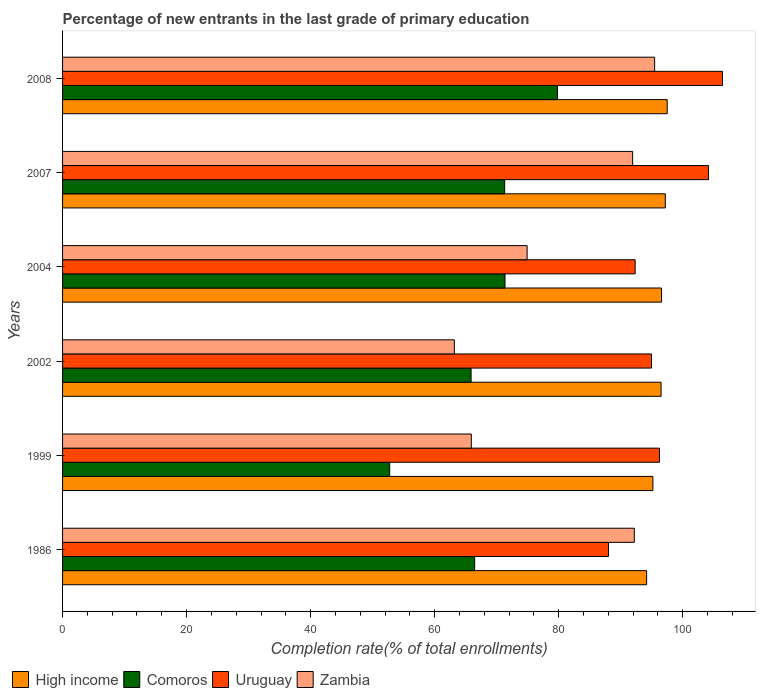How many groups of bars are there?
Your answer should be compact. 6. Are the number of bars on each tick of the Y-axis equal?
Provide a short and direct response. Yes. How many bars are there on the 1st tick from the bottom?
Provide a succinct answer. 4. What is the label of the 2nd group of bars from the top?
Your answer should be compact. 2007. In how many cases, is the number of bars for a given year not equal to the number of legend labels?
Make the answer very short. 0. What is the percentage of new entrants in Comoros in 2002?
Keep it short and to the point. 65.88. Across all years, what is the maximum percentage of new entrants in High income?
Offer a very short reply. 97.5. Across all years, what is the minimum percentage of new entrants in Uruguay?
Give a very brief answer. 88.04. What is the total percentage of new entrants in Uruguay in the graph?
Offer a very short reply. 582.19. What is the difference between the percentage of new entrants in High income in 1986 and that in 2008?
Offer a very short reply. -3.32. What is the difference between the percentage of new entrants in Uruguay in 2008 and the percentage of new entrants in Comoros in 2007?
Your response must be concise. 35.12. What is the average percentage of new entrants in Comoros per year?
Your answer should be very brief. 67.92. In the year 2004, what is the difference between the percentage of new entrants in High income and percentage of new entrants in Zambia?
Your answer should be very brief. 21.68. In how many years, is the percentage of new entrants in Uruguay greater than 60 %?
Provide a succinct answer. 6. What is the ratio of the percentage of new entrants in High income in 2002 to that in 2007?
Provide a succinct answer. 0.99. Is the difference between the percentage of new entrants in High income in 1986 and 2007 greater than the difference between the percentage of new entrants in Zambia in 1986 and 2007?
Your answer should be very brief. No. What is the difference between the highest and the second highest percentage of new entrants in Zambia?
Your answer should be compact. 3.28. What is the difference between the highest and the lowest percentage of new entrants in Comoros?
Give a very brief answer. 27.06. In how many years, is the percentage of new entrants in Comoros greater than the average percentage of new entrants in Comoros taken over all years?
Your answer should be very brief. 3. Is it the case that in every year, the sum of the percentage of new entrants in Uruguay and percentage of new entrants in Comoros is greater than the sum of percentage of new entrants in Zambia and percentage of new entrants in High income?
Your answer should be compact. No. What does the 1st bar from the top in 2002 represents?
Your response must be concise. Zambia. What does the 3rd bar from the bottom in 1999 represents?
Ensure brevity in your answer.  Uruguay. Is it the case that in every year, the sum of the percentage of new entrants in Zambia and percentage of new entrants in Uruguay is greater than the percentage of new entrants in High income?
Ensure brevity in your answer.  Yes. How many bars are there?
Offer a very short reply. 24. Are all the bars in the graph horizontal?
Offer a very short reply. Yes. How many years are there in the graph?
Provide a succinct answer. 6. Are the values on the major ticks of X-axis written in scientific E-notation?
Keep it short and to the point. No. Does the graph contain any zero values?
Provide a succinct answer. No. Does the graph contain grids?
Offer a very short reply. No. Where does the legend appear in the graph?
Your answer should be compact. Bottom left. How many legend labels are there?
Provide a succinct answer. 4. How are the legend labels stacked?
Give a very brief answer. Horizontal. What is the title of the graph?
Your answer should be very brief. Percentage of new entrants in the last grade of primary education. What is the label or title of the X-axis?
Keep it short and to the point. Completion rate(% of total enrollments). What is the label or title of the Y-axis?
Provide a succinct answer. Years. What is the Completion rate(% of total enrollments) of High income in 1986?
Your response must be concise. 94.19. What is the Completion rate(% of total enrollments) of Comoros in 1986?
Keep it short and to the point. 66.46. What is the Completion rate(% of total enrollments) in Uruguay in 1986?
Your response must be concise. 88.04. What is the Completion rate(% of total enrollments) of Zambia in 1986?
Your answer should be very brief. 92.2. What is the Completion rate(% of total enrollments) of High income in 1999?
Offer a very short reply. 95.2. What is the Completion rate(% of total enrollments) in Comoros in 1999?
Give a very brief answer. 52.75. What is the Completion rate(% of total enrollments) of Uruguay in 1999?
Provide a succinct answer. 96.25. What is the Completion rate(% of total enrollments) in Zambia in 1999?
Give a very brief answer. 65.92. What is the Completion rate(% of total enrollments) in High income in 2002?
Provide a short and direct response. 96.52. What is the Completion rate(% of total enrollments) in Comoros in 2002?
Offer a very short reply. 65.88. What is the Completion rate(% of total enrollments) in Uruguay in 2002?
Offer a terse response. 94.98. What is the Completion rate(% of total enrollments) of Zambia in 2002?
Provide a short and direct response. 63.18. What is the Completion rate(% of total enrollments) in High income in 2004?
Your answer should be very brief. 96.59. What is the Completion rate(% of total enrollments) of Comoros in 2004?
Your answer should be compact. 71.35. What is the Completion rate(% of total enrollments) in Uruguay in 2004?
Your answer should be very brief. 92.34. What is the Completion rate(% of total enrollments) in Zambia in 2004?
Offer a very short reply. 74.91. What is the Completion rate(% of total enrollments) in High income in 2007?
Provide a succinct answer. 97.2. What is the Completion rate(% of total enrollments) of Comoros in 2007?
Make the answer very short. 71.3. What is the Completion rate(% of total enrollments) in Uruguay in 2007?
Give a very brief answer. 104.17. What is the Completion rate(% of total enrollments) in Zambia in 2007?
Offer a very short reply. 91.93. What is the Completion rate(% of total enrollments) of High income in 2008?
Give a very brief answer. 97.5. What is the Completion rate(% of total enrollments) in Comoros in 2008?
Give a very brief answer. 79.82. What is the Completion rate(% of total enrollments) in Uruguay in 2008?
Your answer should be compact. 106.42. What is the Completion rate(% of total enrollments) of Zambia in 2008?
Give a very brief answer. 95.47. Across all years, what is the maximum Completion rate(% of total enrollments) in High income?
Your response must be concise. 97.5. Across all years, what is the maximum Completion rate(% of total enrollments) of Comoros?
Make the answer very short. 79.82. Across all years, what is the maximum Completion rate(% of total enrollments) of Uruguay?
Your answer should be very brief. 106.42. Across all years, what is the maximum Completion rate(% of total enrollments) of Zambia?
Your answer should be very brief. 95.47. Across all years, what is the minimum Completion rate(% of total enrollments) of High income?
Provide a succinct answer. 94.19. Across all years, what is the minimum Completion rate(% of total enrollments) in Comoros?
Your response must be concise. 52.75. Across all years, what is the minimum Completion rate(% of total enrollments) of Uruguay?
Your answer should be compact. 88.04. Across all years, what is the minimum Completion rate(% of total enrollments) of Zambia?
Provide a short and direct response. 63.18. What is the total Completion rate(% of total enrollments) of High income in the graph?
Give a very brief answer. 577.19. What is the total Completion rate(% of total enrollments) of Comoros in the graph?
Give a very brief answer. 407.54. What is the total Completion rate(% of total enrollments) in Uruguay in the graph?
Keep it short and to the point. 582.19. What is the total Completion rate(% of total enrollments) in Zambia in the graph?
Offer a very short reply. 483.61. What is the difference between the Completion rate(% of total enrollments) in High income in 1986 and that in 1999?
Offer a terse response. -1.01. What is the difference between the Completion rate(% of total enrollments) of Comoros in 1986 and that in 1999?
Offer a very short reply. 13.7. What is the difference between the Completion rate(% of total enrollments) of Uruguay in 1986 and that in 1999?
Your response must be concise. -8.22. What is the difference between the Completion rate(% of total enrollments) in Zambia in 1986 and that in 1999?
Provide a short and direct response. 26.28. What is the difference between the Completion rate(% of total enrollments) of High income in 1986 and that in 2002?
Provide a short and direct response. -2.33. What is the difference between the Completion rate(% of total enrollments) of Comoros in 1986 and that in 2002?
Offer a terse response. 0.58. What is the difference between the Completion rate(% of total enrollments) of Uruguay in 1986 and that in 2002?
Keep it short and to the point. -6.94. What is the difference between the Completion rate(% of total enrollments) of Zambia in 1986 and that in 2002?
Your response must be concise. 29.02. What is the difference between the Completion rate(% of total enrollments) in High income in 1986 and that in 2004?
Ensure brevity in your answer.  -2.41. What is the difference between the Completion rate(% of total enrollments) in Comoros in 1986 and that in 2004?
Provide a short and direct response. -4.89. What is the difference between the Completion rate(% of total enrollments) of Uruguay in 1986 and that in 2004?
Offer a very short reply. -4.3. What is the difference between the Completion rate(% of total enrollments) of Zambia in 1986 and that in 2004?
Offer a very short reply. 17.29. What is the difference between the Completion rate(% of total enrollments) in High income in 1986 and that in 2007?
Offer a terse response. -3.01. What is the difference between the Completion rate(% of total enrollments) in Comoros in 1986 and that in 2007?
Your answer should be very brief. -4.84. What is the difference between the Completion rate(% of total enrollments) in Uruguay in 1986 and that in 2007?
Offer a terse response. -16.13. What is the difference between the Completion rate(% of total enrollments) in Zambia in 1986 and that in 2007?
Offer a very short reply. 0.27. What is the difference between the Completion rate(% of total enrollments) in High income in 1986 and that in 2008?
Your answer should be very brief. -3.32. What is the difference between the Completion rate(% of total enrollments) in Comoros in 1986 and that in 2008?
Give a very brief answer. -13.36. What is the difference between the Completion rate(% of total enrollments) of Uruguay in 1986 and that in 2008?
Make the answer very short. -18.39. What is the difference between the Completion rate(% of total enrollments) of Zambia in 1986 and that in 2008?
Your response must be concise. -3.28. What is the difference between the Completion rate(% of total enrollments) in High income in 1999 and that in 2002?
Provide a short and direct response. -1.32. What is the difference between the Completion rate(% of total enrollments) of Comoros in 1999 and that in 2002?
Keep it short and to the point. -13.13. What is the difference between the Completion rate(% of total enrollments) of Uruguay in 1999 and that in 2002?
Offer a terse response. 1.28. What is the difference between the Completion rate(% of total enrollments) of Zambia in 1999 and that in 2002?
Keep it short and to the point. 2.74. What is the difference between the Completion rate(% of total enrollments) of High income in 1999 and that in 2004?
Provide a succinct answer. -1.4. What is the difference between the Completion rate(% of total enrollments) in Comoros in 1999 and that in 2004?
Provide a succinct answer. -18.6. What is the difference between the Completion rate(% of total enrollments) in Uruguay in 1999 and that in 2004?
Provide a succinct answer. 3.92. What is the difference between the Completion rate(% of total enrollments) of Zambia in 1999 and that in 2004?
Your response must be concise. -9. What is the difference between the Completion rate(% of total enrollments) in High income in 1999 and that in 2007?
Make the answer very short. -2. What is the difference between the Completion rate(% of total enrollments) in Comoros in 1999 and that in 2007?
Offer a terse response. -18.55. What is the difference between the Completion rate(% of total enrollments) in Uruguay in 1999 and that in 2007?
Offer a very short reply. -7.91. What is the difference between the Completion rate(% of total enrollments) in Zambia in 1999 and that in 2007?
Your answer should be compact. -26.02. What is the difference between the Completion rate(% of total enrollments) of High income in 1999 and that in 2008?
Your response must be concise. -2.31. What is the difference between the Completion rate(% of total enrollments) of Comoros in 1999 and that in 2008?
Your response must be concise. -27.06. What is the difference between the Completion rate(% of total enrollments) in Uruguay in 1999 and that in 2008?
Give a very brief answer. -10.17. What is the difference between the Completion rate(% of total enrollments) in Zambia in 1999 and that in 2008?
Ensure brevity in your answer.  -29.56. What is the difference between the Completion rate(% of total enrollments) of High income in 2002 and that in 2004?
Provide a succinct answer. -0.08. What is the difference between the Completion rate(% of total enrollments) of Comoros in 2002 and that in 2004?
Your response must be concise. -5.47. What is the difference between the Completion rate(% of total enrollments) of Uruguay in 2002 and that in 2004?
Offer a terse response. 2.64. What is the difference between the Completion rate(% of total enrollments) in Zambia in 2002 and that in 2004?
Keep it short and to the point. -11.74. What is the difference between the Completion rate(% of total enrollments) of High income in 2002 and that in 2007?
Give a very brief answer. -0.68. What is the difference between the Completion rate(% of total enrollments) in Comoros in 2002 and that in 2007?
Your answer should be very brief. -5.42. What is the difference between the Completion rate(% of total enrollments) of Uruguay in 2002 and that in 2007?
Offer a very short reply. -9.19. What is the difference between the Completion rate(% of total enrollments) in Zambia in 2002 and that in 2007?
Ensure brevity in your answer.  -28.75. What is the difference between the Completion rate(% of total enrollments) in High income in 2002 and that in 2008?
Provide a short and direct response. -0.99. What is the difference between the Completion rate(% of total enrollments) of Comoros in 2002 and that in 2008?
Offer a very short reply. -13.94. What is the difference between the Completion rate(% of total enrollments) in Uruguay in 2002 and that in 2008?
Give a very brief answer. -11.44. What is the difference between the Completion rate(% of total enrollments) of Zambia in 2002 and that in 2008?
Offer a very short reply. -32.3. What is the difference between the Completion rate(% of total enrollments) of High income in 2004 and that in 2007?
Your response must be concise. -0.61. What is the difference between the Completion rate(% of total enrollments) of Comoros in 2004 and that in 2007?
Offer a terse response. 0.05. What is the difference between the Completion rate(% of total enrollments) of Uruguay in 2004 and that in 2007?
Provide a succinct answer. -11.83. What is the difference between the Completion rate(% of total enrollments) in Zambia in 2004 and that in 2007?
Make the answer very short. -17.02. What is the difference between the Completion rate(% of total enrollments) in High income in 2004 and that in 2008?
Make the answer very short. -0.91. What is the difference between the Completion rate(% of total enrollments) of Comoros in 2004 and that in 2008?
Your answer should be very brief. -8.47. What is the difference between the Completion rate(% of total enrollments) in Uruguay in 2004 and that in 2008?
Give a very brief answer. -14.08. What is the difference between the Completion rate(% of total enrollments) in Zambia in 2004 and that in 2008?
Your answer should be very brief. -20.56. What is the difference between the Completion rate(% of total enrollments) of High income in 2007 and that in 2008?
Provide a short and direct response. -0.3. What is the difference between the Completion rate(% of total enrollments) of Comoros in 2007 and that in 2008?
Provide a succinct answer. -8.52. What is the difference between the Completion rate(% of total enrollments) in Uruguay in 2007 and that in 2008?
Ensure brevity in your answer.  -2.25. What is the difference between the Completion rate(% of total enrollments) of Zambia in 2007 and that in 2008?
Keep it short and to the point. -3.54. What is the difference between the Completion rate(% of total enrollments) in High income in 1986 and the Completion rate(% of total enrollments) in Comoros in 1999?
Your response must be concise. 41.44. What is the difference between the Completion rate(% of total enrollments) in High income in 1986 and the Completion rate(% of total enrollments) in Uruguay in 1999?
Provide a succinct answer. -2.07. What is the difference between the Completion rate(% of total enrollments) in High income in 1986 and the Completion rate(% of total enrollments) in Zambia in 1999?
Keep it short and to the point. 28.27. What is the difference between the Completion rate(% of total enrollments) of Comoros in 1986 and the Completion rate(% of total enrollments) of Uruguay in 1999?
Keep it short and to the point. -29.8. What is the difference between the Completion rate(% of total enrollments) of Comoros in 1986 and the Completion rate(% of total enrollments) of Zambia in 1999?
Offer a very short reply. 0.54. What is the difference between the Completion rate(% of total enrollments) in Uruguay in 1986 and the Completion rate(% of total enrollments) in Zambia in 1999?
Provide a short and direct response. 22.12. What is the difference between the Completion rate(% of total enrollments) of High income in 1986 and the Completion rate(% of total enrollments) of Comoros in 2002?
Your answer should be compact. 28.31. What is the difference between the Completion rate(% of total enrollments) of High income in 1986 and the Completion rate(% of total enrollments) of Uruguay in 2002?
Give a very brief answer. -0.79. What is the difference between the Completion rate(% of total enrollments) in High income in 1986 and the Completion rate(% of total enrollments) in Zambia in 2002?
Offer a terse response. 31.01. What is the difference between the Completion rate(% of total enrollments) of Comoros in 1986 and the Completion rate(% of total enrollments) of Uruguay in 2002?
Provide a succinct answer. -28.52. What is the difference between the Completion rate(% of total enrollments) of Comoros in 1986 and the Completion rate(% of total enrollments) of Zambia in 2002?
Your answer should be compact. 3.28. What is the difference between the Completion rate(% of total enrollments) of Uruguay in 1986 and the Completion rate(% of total enrollments) of Zambia in 2002?
Make the answer very short. 24.86. What is the difference between the Completion rate(% of total enrollments) in High income in 1986 and the Completion rate(% of total enrollments) in Comoros in 2004?
Provide a succinct answer. 22.84. What is the difference between the Completion rate(% of total enrollments) of High income in 1986 and the Completion rate(% of total enrollments) of Uruguay in 2004?
Provide a succinct answer. 1.85. What is the difference between the Completion rate(% of total enrollments) in High income in 1986 and the Completion rate(% of total enrollments) in Zambia in 2004?
Give a very brief answer. 19.27. What is the difference between the Completion rate(% of total enrollments) in Comoros in 1986 and the Completion rate(% of total enrollments) in Uruguay in 2004?
Provide a short and direct response. -25.88. What is the difference between the Completion rate(% of total enrollments) of Comoros in 1986 and the Completion rate(% of total enrollments) of Zambia in 2004?
Give a very brief answer. -8.46. What is the difference between the Completion rate(% of total enrollments) of Uruguay in 1986 and the Completion rate(% of total enrollments) of Zambia in 2004?
Give a very brief answer. 13.12. What is the difference between the Completion rate(% of total enrollments) of High income in 1986 and the Completion rate(% of total enrollments) of Comoros in 2007?
Provide a short and direct response. 22.89. What is the difference between the Completion rate(% of total enrollments) of High income in 1986 and the Completion rate(% of total enrollments) of Uruguay in 2007?
Your answer should be compact. -9.98. What is the difference between the Completion rate(% of total enrollments) in High income in 1986 and the Completion rate(% of total enrollments) in Zambia in 2007?
Keep it short and to the point. 2.25. What is the difference between the Completion rate(% of total enrollments) of Comoros in 1986 and the Completion rate(% of total enrollments) of Uruguay in 2007?
Keep it short and to the point. -37.71. What is the difference between the Completion rate(% of total enrollments) in Comoros in 1986 and the Completion rate(% of total enrollments) in Zambia in 2007?
Keep it short and to the point. -25.48. What is the difference between the Completion rate(% of total enrollments) of Uruguay in 1986 and the Completion rate(% of total enrollments) of Zambia in 2007?
Provide a short and direct response. -3.9. What is the difference between the Completion rate(% of total enrollments) of High income in 1986 and the Completion rate(% of total enrollments) of Comoros in 2008?
Keep it short and to the point. 14.37. What is the difference between the Completion rate(% of total enrollments) in High income in 1986 and the Completion rate(% of total enrollments) in Uruguay in 2008?
Make the answer very short. -12.23. What is the difference between the Completion rate(% of total enrollments) of High income in 1986 and the Completion rate(% of total enrollments) of Zambia in 2008?
Provide a short and direct response. -1.29. What is the difference between the Completion rate(% of total enrollments) of Comoros in 1986 and the Completion rate(% of total enrollments) of Uruguay in 2008?
Provide a short and direct response. -39.96. What is the difference between the Completion rate(% of total enrollments) in Comoros in 1986 and the Completion rate(% of total enrollments) in Zambia in 2008?
Your response must be concise. -29.02. What is the difference between the Completion rate(% of total enrollments) of Uruguay in 1986 and the Completion rate(% of total enrollments) of Zambia in 2008?
Offer a terse response. -7.44. What is the difference between the Completion rate(% of total enrollments) of High income in 1999 and the Completion rate(% of total enrollments) of Comoros in 2002?
Provide a succinct answer. 29.32. What is the difference between the Completion rate(% of total enrollments) in High income in 1999 and the Completion rate(% of total enrollments) in Uruguay in 2002?
Your response must be concise. 0.22. What is the difference between the Completion rate(% of total enrollments) in High income in 1999 and the Completion rate(% of total enrollments) in Zambia in 2002?
Provide a short and direct response. 32.02. What is the difference between the Completion rate(% of total enrollments) in Comoros in 1999 and the Completion rate(% of total enrollments) in Uruguay in 2002?
Keep it short and to the point. -42.23. What is the difference between the Completion rate(% of total enrollments) of Comoros in 1999 and the Completion rate(% of total enrollments) of Zambia in 2002?
Your answer should be compact. -10.43. What is the difference between the Completion rate(% of total enrollments) of Uruguay in 1999 and the Completion rate(% of total enrollments) of Zambia in 2002?
Offer a very short reply. 33.08. What is the difference between the Completion rate(% of total enrollments) in High income in 1999 and the Completion rate(% of total enrollments) in Comoros in 2004?
Your response must be concise. 23.85. What is the difference between the Completion rate(% of total enrollments) of High income in 1999 and the Completion rate(% of total enrollments) of Uruguay in 2004?
Provide a short and direct response. 2.86. What is the difference between the Completion rate(% of total enrollments) of High income in 1999 and the Completion rate(% of total enrollments) of Zambia in 2004?
Offer a very short reply. 20.28. What is the difference between the Completion rate(% of total enrollments) in Comoros in 1999 and the Completion rate(% of total enrollments) in Uruguay in 2004?
Give a very brief answer. -39.59. What is the difference between the Completion rate(% of total enrollments) of Comoros in 1999 and the Completion rate(% of total enrollments) of Zambia in 2004?
Make the answer very short. -22.16. What is the difference between the Completion rate(% of total enrollments) of Uruguay in 1999 and the Completion rate(% of total enrollments) of Zambia in 2004?
Give a very brief answer. 21.34. What is the difference between the Completion rate(% of total enrollments) in High income in 1999 and the Completion rate(% of total enrollments) in Comoros in 2007?
Ensure brevity in your answer.  23.9. What is the difference between the Completion rate(% of total enrollments) of High income in 1999 and the Completion rate(% of total enrollments) of Uruguay in 2007?
Offer a very short reply. -8.97. What is the difference between the Completion rate(% of total enrollments) in High income in 1999 and the Completion rate(% of total enrollments) in Zambia in 2007?
Give a very brief answer. 3.26. What is the difference between the Completion rate(% of total enrollments) of Comoros in 1999 and the Completion rate(% of total enrollments) of Uruguay in 2007?
Your answer should be compact. -51.42. What is the difference between the Completion rate(% of total enrollments) of Comoros in 1999 and the Completion rate(% of total enrollments) of Zambia in 2007?
Offer a very short reply. -39.18. What is the difference between the Completion rate(% of total enrollments) of Uruguay in 1999 and the Completion rate(% of total enrollments) of Zambia in 2007?
Ensure brevity in your answer.  4.32. What is the difference between the Completion rate(% of total enrollments) in High income in 1999 and the Completion rate(% of total enrollments) in Comoros in 2008?
Your answer should be compact. 15.38. What is the difference between the Completion rate(% of total enrollments) of High income in 1999 and the Completion rate(% of total enrollments) of Uruguay in 2008?
Give a very brief answer. -11.22. What is the difference between the Completion rate(% of total enrollments) in High income in 1999 and the Completion rate(% of total enrollments) in Zambia in 2008?
Provide a short and direct response. -0.28. What is the difference between the Completion rate(% of total enrollments) in Comoros in 1999 and the Completion rate(% of total enrollments) in Uruguay in 2008?
Provide a succinct answer. -53.67. What is the difference between the Completion rate(% of total enrollments) of Comoros in 1999 and the Completion rate(% of total enrollments) of Zambia in 2008?
Your answer should be compact. -42.72. What is the difference between the Completion rate(% of total enrollments) in Uruguay in 1999 and the Completion rate(% of total enrollments) in Zambia in 2008?
Provide a succinct answer. 0.78. What is the difference between the Completion rate(% of total enrollments) in High income in 2002 and the Completion rate(% of total enrollments) in Comoros in 2004?
Provide a short and direct response. 25.17. What is the difference between the Completion rate(% of total enrollments) of High income in 2002 and the Completion rate(% of total enrollments) of Uruguay in 2004?
Your answer should be very brief. 4.18. What is the difference between the Completion rate(% of total enrollments) in High income in 2002 and the Completion rate(% of total enrollments) in Zambia in 2004?
Your response must be concise. 21.6. What is the difference between the Completion rate(% of total enrollments) of Comoros in 2002 and the Completion rate(% of total enrollments) of Uruguay in 2004?
Offer a terse response. -26.46. What is the difference between the Completion rate(% of total enrollments) of Comoros in 2002 and the Completion rate(% of total enrollments) of Zambia in 2004?
Your answer should be very brief. -9.03. What is the difference between the Completion rate(% of total enrollments) of Uruguay in 2002 and the Completion rate(% of total enrollments) of Zambia in 2004?
Your answer should be very brief. 20.06. What is the difference between the Completion rate(% of total enrollments) in High income in 2002 and the Completion rate(% of total enrollments) in Comoros in 2007?
Ensure brevity in your answer.  25.22. What is the difference between the Completion rate(% of total enrollments) in High income in 2002 and the Completion rate(% of total enrollments) in Uruguay in 2007?
Your response must be concise. -7.65. What is the difference between the Completion rate(% of total enrollments) in High income in 2002 and the Completion rate(% of total enrollments) in Zambia in 2007?
Keep it short and to the point. 4.58. What is the difference between the Completion rate(% of total enrollments) of Comoros in 2002 and the Completion rate(% of total enrollments) of Uruguay in 2007?
Give a very brief answer. -38.29. What is the difference between the Completion rate(% of total enrollments) of Comoros in 2002 and the Completion rate(% of total enrollments) of Zambia in 2007?
Give a very brief answer. -26.05. What is the difference between the Completion rate(% of total enrollments) in Uruguay in 2002 and the Completion rate(% of total enrollments) in Zambia in 2007?
Ensure brevity in your answer.  3.04. What is the difference between the Completion rate(% of total enrollments) in High income in 2002 and the Completion rate(% of total enrollments) in Comoros in 2008?
Offer a terse response. 16.7. What is the difference between the Completion rate(% of total enrollments) of High income in 2002 and the Completion rate(% of total enrollments) of Uruguay in 2008?
Your answer should be compact. -9.9. What is the difference between the Completion rate(% of total enrollments) of High income in 2002 and the Completion rate(% of total enrollments) of Zambia in 2008?
Ensure brevity in your answer.  1.04. What is the difference between the Completion rate(% of total enrollments) of Comoros in 2002 and the Completion rate(% of total enrollments) of Uruguay in 2008?
Your answer should be compact. -40.54. What is the difference between the Completion rate(% of total enrollments) in Comoros in 2002 and the Completion rate(% of total enrollments) in Zambia in 2008?
Your response must be concise. -29.6. What is the difference between the Completion rate(% of total enrollments) of Uruguay in 2002 and the Completion rate(% of total enrollments) of Zambia in 2008?
Keep it short and to the point. -0.5. What is the difference between the Completion rate(% of total enrollments) of High income in 2004 and the Completion rate(% of total enrollments) of Comoros in 2007?
Keep it short and to the point. 25.3. What is the difference between the Completion rate(% of total enrollments) of High income in 2004 and the Completion rate(% of total enrollments) of Uruguay in 2007?
Keep it short and to the point. -7.58. What is the difference between the Completion rate(% of total enrollments) in High income in 2004 and the Completion rate(% of total enrollments) in Zambia in 2007?
Keep it short and to the point. 4.66. What is the difference between the Completion rate(% of total enrollments) in Comoros in 2004 and the Completion rate(% of total enrollments) in Uruguay in 2007?
Make the answer very short. -32.82. What is the difference between the Completion rate(% of total enrollments) in Comoros in 2004 and the Completion rate(% of total enrollments) in Zambia in 2007?
Provide a short and direct response. -20.59. What is the difference between the Completion rate(% of total enrollments) in Uruguay in 2004 and the Completion rate(% of total enrollments) in Zambia in 2007?
Your answer should be very brief. 0.41. What is the difference between the Completion rate(% of total enrollments) of High income in 2004 and the Completion rate(% of total enrollments) of Comoros in 2008?
Offer a very short reply. 16.78. What is the difference between the Completion rate(% of total enrollments) in High income in 2004 and the Completion rate(% of total enrollments) in Uruguay in 2008?
Ensure brevity in your answer.  -9.83. What is the difference between the Completion rate(% of total enrollments) in High income in 2004 and the Completion rate(% of total enrollments) in Zambia in 2008?
Your answer should be very brief. 1.12. What is the difference between the Completion rate(% of total enrollments) of Comoros in 2004 and the Completion rate(% of total enrollments) of Uruguay in 2008?
Offer a terse response. -35.07. What is the difference between the Completion rate(% of total enrollments) of Comoros in 2004 and the Completion rate(% of total enrollments) of Zambia in 2008?
Give a very brief answer. -24.13. What is the difference between the Completion rate(% of total enrollments) of Uruguay in 2004 and the Completion rate(% of total enrollments) of Zambia in 2008?
Offer a terse response. -3.14. What is the difference between the Completion rate(% of total enrollments) of High income in 2007 and the Completion rate(% of total enrollments) of Comoros in 2008?
Ensure brevity in your answer.  17.38. What is the difference between the Completion rate(% of total enrollments) of High income in 2007 and the Completion rate(% of total enrollments) of Uruguay in 2008?
Provide a succinct answer. -9.22. What is the difference between the Completion rate(% of total enrollments) in High income in 2007 and the Completion rate(% of total enrollments) in Zambia in 2008?
Ensure brevity in your answer.  1.72. What is the difference between the Completion rate(% of total enrollments) in Comoros in 2007 and the Completion rate(% of total enrollments) in Uruguay in 2008?
Provide a short and direct response. -35.12. What is the difference between the Completion rate(% of total enrollments) of Comoros in 2007 and the Completion rate(% of total enrollments) of Zambia in 2008?
Ensure brevity in your answer.  -24.18. What is the difference between the Completion rate(% of total enrollments) in Uruguay in 2007 and the Completion rate(% of total enrollments) in Zambia in 2008?
Your answer should be very brief. 8.69. What is the average Completion rate(% of total enrollments) in High income per year?
Keep it short and to the point. 96.2. What is the average Completion rate(% of total enrollments) of Comoros per year?
Offer a very short reply. 67.92. What is the average Completion rate(% of total enrollments) in Uruguay per year?
Provide a succinct answer. 97.03. What is the average Completion rate(% of total enrollments) in Zambia per year?
Your response must be concise. 80.6. In the year 1986, what is the difference between the Completion rate(% of total enrollments) in High income and Completion rate(% of total enrollments) in Comoros?
Offer a very short reply. 27.73. In the year 1986, what is the difference between the Completion rate(% of total enrollments) in High income and Completion rate(% of total enrollments) in Uruguay?
Your response must be concise. 6.15. In the year 1986, what is the difference between the Completion rate(% of total enrollments) in High income and Completion rate(% of total enrollments) in Zambia?
Make the answer very short. 1.99. In the year 1986, what is the difference between the Completion rate(% of total enrollments) in Comoros and Completion rate(% of total enrollments) in Uruguay?
Provide a short and direct response. -21.58. In the year 1986, what is the difference between the Completion rate(% of total enrollments) of Comoros and Completion rate(% of total enrollments) of Zambia?
Your response must be concise. -25.74. In the year 1986, what is the difference between the Completion rate(% of total enrollments) of Uruguay and Completion rate(% of total enrollments) of Zambia?
Your answer should be very brief. -4.16. In the year 1999, what is the difference between the Completion rate(% of total enrollments) in High income and Completion rate(% of total enrollments) in Comoros?
Make the answer very short. 42.45. In the year 1999, what is the difference between the Completion rate(% of total enrollments) in High income and Completion rate(% of total enrollments) in Uruguay?
Make the answer very short. -1.06. In the year 1999, what is the difference between the Completion rate(% of total enrollments) in High income and Completion rate(% of total enrollments) in Zambia?
Your answer should be very brief. 29.28. In the year 1999, what is the difference between the Completion rate(% of total enrollments) of Comoros and Completion rate(% of total enrollments) of Uruguay?
Your answer should be very brief. -43.5. In the year 1999, what is the difference between the Completion rate(% of total enrollments) of Comoros and Completion rate(% of total enrollments) of Zambia?
Give a very brief answer. -13.16. In the year 1999, what is the difference between the Completion rate(% of total enrollments) in Uruguay and Completion rate(% of total enrollments) in Zambia?
Offer a very short reply. 30.34. In the year 2002, what is the difference between the Completion rate(% of total enrollments) of High income and Completion rate(% of total enrollments) of Comoros?
Offer a very short reply. 30.64. In the year 2002, what is the difference between the Completion rate(% of total enrollments) of High income and Completion rate(% of total enrollments) of Uruguay?
Give a very brief answer. 1.54. In the year 2002, what is the difference between the Completion rate(% of total enrollments) in High income and Completion rate(% of total enrollments) in Zambia?
Make the answer very short. 33.34. In the year 2002, what is the difference between the Completion rate(% of total enrollments) in Comoros and Completion rate(% of total enrollments) in Uruguay?
Keep it short and to the point. -29.1. In the year 2002, what is the difference between the Completion rate(% of total enrollments) of Comoros and Completion rate(% of total enrollments) of Zambia?
Keep it short and to the point. 2.7. In the year 2002, what is the difference between the Completion rate(% of total enrollments) in Uruguay and Completion rate(% of total enrollments) in Zambia?
Offer a very short reply. 31.8. In the year 2004, what is the difference between the Completion rate(% of total enrollments) in High income and Completion rate(% of total enrollments) in Comoros?
Make the answer very short. 25.25. In the year 2004, what is the difference between the Completion rate(% of total enrollments) of High income and Completion rate(% of total enrollments) of Uruguay?
Offer a terse response. 4.25. In the year 2004, what is the difference between the Completion rate(% of total enrollments) of High income and Completion rate(% of total enrollments) of Zambia?
Your answer should be compact. 21.68. In the year 2004, what is the difference between the Completion rate(% of total enrollments) of Comoros and Completion rate(% of total enrollments) of Uruguay?
Your answer should be very brief. -20.99. In the year 2004, what is the difference between the Completion rate(% of total enrollments) of Comoros and Completion rate(% of total enrollments) of Zambia?
Offer a very short reply. -3.57. In the year 2004, what is the difference between the Completion rate(% of total enrollments) in Uruguay and Completion rate(% of total enrollments) in Zambia?
Keep it short and to the point. 17.42. In the year 2007, what is the difference between the Completion rate(% of total enrollments) of High income and Completion rate(% of total enrollments) of Comoros?
Keep it short and to the point. 25.9. In the year 2007, what is the difference between the Completion rate(% of total enrollments) in High income and Completion rate(% of total enrollments) in Uruguay?
Provide a succinct answer. -6.97. In the year 2007, what is the difference between the Completion rate(% of total enrollments) of High income and Completion rate(% of total enrollments) of Zambia?
Provide a short and direct response. 5.27. In the year 2007, what is the difference between the Completion rate(% of total enrollments) of Comoros and Completion rate(% of total enrollments) of Uruguay?
Your answer should be compact. -32.87. In the year 2007, what is the difference between the Completion rate(% of total enrollments) in Comoros and Completion rate(% of total enrollments) in Zambia?
Your response must be concise. -20.64. In the year 2007, what is the difference between the Completion rate(% of total enrollments) of Uruguay and Completion rate(% of total enrollments) of Zambia?
Provide a succinct answer. 12.24. In the year 2008, what is the difference between the Completion rate(% of total enrollments) of High income and Completion rate(% of total enrollments) of Comoros?
Make the answer very short. 17.69. In the year 2008, what is the difference between the Completion rate(% of total enrollments) in High income and Completion rate(% of total enrollments) in Uruguay?
Offer a terse response. -8.92. In the year 2008, what is the difference between the Completion rate(% of total enrollments) in High income and Completion rate(% of total enrollments) in Zambia?
Keep it short and to the point. 2.03. In the year 2008, what is the difference between the Completion rate(% of total enrollments) in Comoros and Completion rate(% of total enrollments) in Uruguay?
Keep it short and to the point. -26.61. In the year 2008, what is the difference between the Completion rate(% of total enrollments) in Comoros and Completion rate(% of total enrollments) in Zambia?
Your answer should be very brief. -15.66. In the year 2008, what is the difference between the Completion rate(% of total enrollments) of Uruguay and Completion rate(% of total enrollments) of Zambia?
Keep it short and to the point. 10.95. What is the ratio of the Completion rate(% of total enrollments) in High income in 1986 to that in 1999?
Your response must be concise. 0.99. What is the ratio of the Completion rate(% of total enrollments) in Comoros in 1986 to that in 1999?
Provide a succinct answer. 1.26. What is the ratio of the Completion rate(% of total enrollments) of Uruguay in 1986 to that in 1999?
Provide a succinct answer. 0.91. What is the ratio of the Completion rate(% of total enrollments) in Zambia in 1986 to that in 1999?
Keep it short and to the point. 1.4. What is the ratio of the Completion rate(% of total enrollments) in High income in 1986 to that in 2002?
Keep it short and to the point. 0.98. What is the ratio of the Completion rate(% of total enrollments) in Comoros in 1986 to that in 2002?
Your answer should be very brief. 1.01. What is the ratio of the Completion rate(% of total enrollments) of Uruguay in 1986 to that in 2002?
Keep it short and to the point. 0.93. What is the ratio of the Completion rate(% of total enrollments) of Zambia in 1986 to that in 2002?
Offer a very short reply. 1.46. What is the ratio of the Completion rate(% of total enrollments) in High income in 1986 to that in 2004?
Give a very brief answer. 0.98. What is the ratio of the Completion rate(% of total enrollments) in Comoros in 1986 to that in 2004?
Offer a very short reply. 0.93. What is the ratio of the Completion rate(% of total enrollments) of Uruguay in 1986 to that in 2004?
Your answer should be compact. 0.95. What is the ratio of the Completion rate(% of total enrollments) in Zambia in 1986 to that in 2004?
Offer a very short reply. 1.23. What is the ratio of the Completion rate(% of total enrollments) of High income in 1986 to that in 2007?
Offer a terse response. 0.97. What is the ratio of the Completion rate(% of total enrollments) of Comoros in 1986 to that in 2007?
Provide a short and direct response. 0.93. What is the ratio of the Completion rate(% of total enrollments) of Uruguay in 1986 to that in 2007?
Offer a terse response. 0.85. What is the ratio of the Completion rate(% of total enrollments) of High income in 1986 to that in 2008?
Your response must be concise. 0.97. What is the ratio of the Completion rate(% of total enrollments) of Comoros in 1986 to that in 2008?
Keep it short and to the point. 0.83. What is the ratio of the Completion rate(% of total enrollments) of Uruguay in 1986 to that in 2008?
Give a very brief answer. 0.83. What is the ratio of the Completion rate(% of total enrollments) in Zambia in 1986 to that in 2008?
Your response must be concise. 0.97. What is the ratio of the Completion rate(% of total enrollments) in High income in 1999 to that in 2002?
Make the answer very short. 0.99. What is the ratio of the Completion rate(% of total enrollments) of Comoros in 1999 to that in 2002?
Provide a short and direct response. 0.8. What is the ratio of the Completion rate(% of total enrollments) in Uruguay in 1999 to that in 2002?
Keep it short and to the point. 1.01. What is the ratio of the Completion rate(% of total enrollments) in Zambia in 1999 to that in 2002?
Make the answer very short. 1.04. What is the ratio of the Completion rate(% of total enrollments) in High income in 1999 to that in 2004?
Offer a very short reply. 0.99. What is the ratio of the Completion rate(% of total enrollments) in Comoros in 1999 to that in 2004?
Ensure brevity in your answer.  0.74. What is the ratio of the Completion rate(% of total enrollments) in Uruguay in 1999 to that in 2004?
Keep it short and to the point. 1.04. What is the ratio of the Completion rate(% of total enrollments) in Zambia in 1999 to that in 2004?
Your answer should be compact. 0.88. What is the ratio of the Completion rate(% of total enrollments) in High income in 1999 to that in 2007?
Provide a succinct answer. 0.98. What is the ratio of the Completion rate(% of total enrollments) of Comoros in 1999 to that in 2007?
Your answer should be very brief. 0.74. What is the ratio of the Completion rate(% of total enrollments) of Uruguay in 1999 to that in 2007?
Give a very brief answer. 0.92. What is the ratio of the Completion rate(% of total enrollments) of Zambia in 1999 to that in 2007?
Offer a terse response. 0.72. What is the ratio of the Completion rate(% of total enrollments) of High income in 1999 to that in 2008?
Provide a short and direct response. 0.98. What is the ratio of the Completion rate(% of total enrollments) of Comoros in 1999 to that in 2008?
Offer a terse response. 0.66. What is the ratio of the Completion rate(% of total enrollments) of Uruguay in 1999 to that in 2008?
Your answer should be very brief. 0.9. What is the ratio of the Completion rate(% of total enrollments) in Zambia in 1999 to that in 2008?
Keep it short and to the point. 0.69. What is the ratio of the Completion rate(% of total enrollments) of Comoros in 2002 to that in 2004?
Provide a short and direct response. 0.92. What is the ratio of the Completion rate(% of total enrollments) in Uruguay in 2002 to that in 2004?
Provide a succinct answer. 1.03. What is the ratio of the Completion rate(% of total enrollments) in Zambia in 2002 to that in 2004?
Ensure brevity in your answer.  0.84. What is the ratio of the Completion rate(% of total enrollments) in High income in 2002 to that in 2007?
Your response must be concise. 0.99. What is the ratio of the Completion rate(% of total enrollments) in Comoros in 2002 to that in 2007?
Offer a very short reply. 0.92. What is the ratio of the Completion rate(% of total enrollments) in Uruguay in 2002 to that in 2007?
Offer a terse response. 0.91. What is the ratio of the Completion rate(% of total enrollments) of Zambia in 2002 to that in 2007?
Give a very brief answer. 0.69. What is the ratio of the Completion rate(% of total enrollments) of High income in 2002 to that in 2008?
Your answer should be very brief. 0.99. What is the ratio of the Completion rate(% of total enrollments) of Comoros in 2002 to that in 2008?
Your response must be concise. 0.83. What is the ratio of the Completion rate(% of total enrollments) in Uruguay in 2002 to that in 2008?
Your response must be concise. 0.89. What is the ratio of the Completion rate(% of total enrollments) of Zambia in 2002 to that in 2008?
Provide a short and direct response. 0.66. What is the ratio of the Completion rate(% of total enrollments) in Uruguay in 2004 to that in 2007?
Provide a short and direct response. 0.89. What is the ratio of the Completion rate(% of total enrollments) in Zambia in 2004 to that in 2007?
Ensure brevity in your answer.  0.81. What is the ratio of the Completion rate(% of total enrollments) of Comoros in 2004 to that in 2008?
Give a very brief answer. 0.89. What is the ratio of the Completion rate(% of total enrollments) of Uruguay in 2004 to that in 2008?
Offer a terse response. 0.87. What is the ratio of the Completion rate(% of total enrollments) in Zambia in 2004 to that in 2008?
Give a very brief answer. 0.78. What is the ratio of the Completion rate(% of total enrollments) of Comoros in 2007 to that in 2008?
Your response must be concise. 0.89. What is the ratio of the Completion rate(% of total enrollments) in Uruguay in 2007 to that in 2008?
Keep it short and to the point. 0.98. What is the ratio of the Completion rate(% of total enrollments) in Zambia in 2007 to that in 2008?
Offer a very short reply. 0.96. What is the difference between the highest and the second highest Completion rate(% of total enrollments) in High income?
Provide a succinct answer. 0.3. What is the difference between the highest and the second highest Completion rate(% of total enrollments) of Comoros?
Make the answer very short. 8.47. What is the difference between the highest and the second highest Completion rate(% of total enrollments) in Uruguay?
Your answer should be compact. 2.25. What is the difference between the highest and the second highest Completion rate(% of total enrollments) of Zambia?
Offer a terse response. 3.28. What is the difference between the highest and the lowest Completion rate(% of total enrollments) of High income?
Provide a short and direct response. 3.32. What is the difference between the highest and the lowest Completion rate(% of total enrollments) of Comoros?
Provide a short and direct response. 27.06. What is the difference between the highest and the lowest Completion rate(% of total enrollments) of Uruguay?
Your answer should be very brief. 18.39. What is the difference between the highest and the lowest Completion rate(% of total enrollments) of Zambia?
Ensure brevity in your answer.  32.3. 